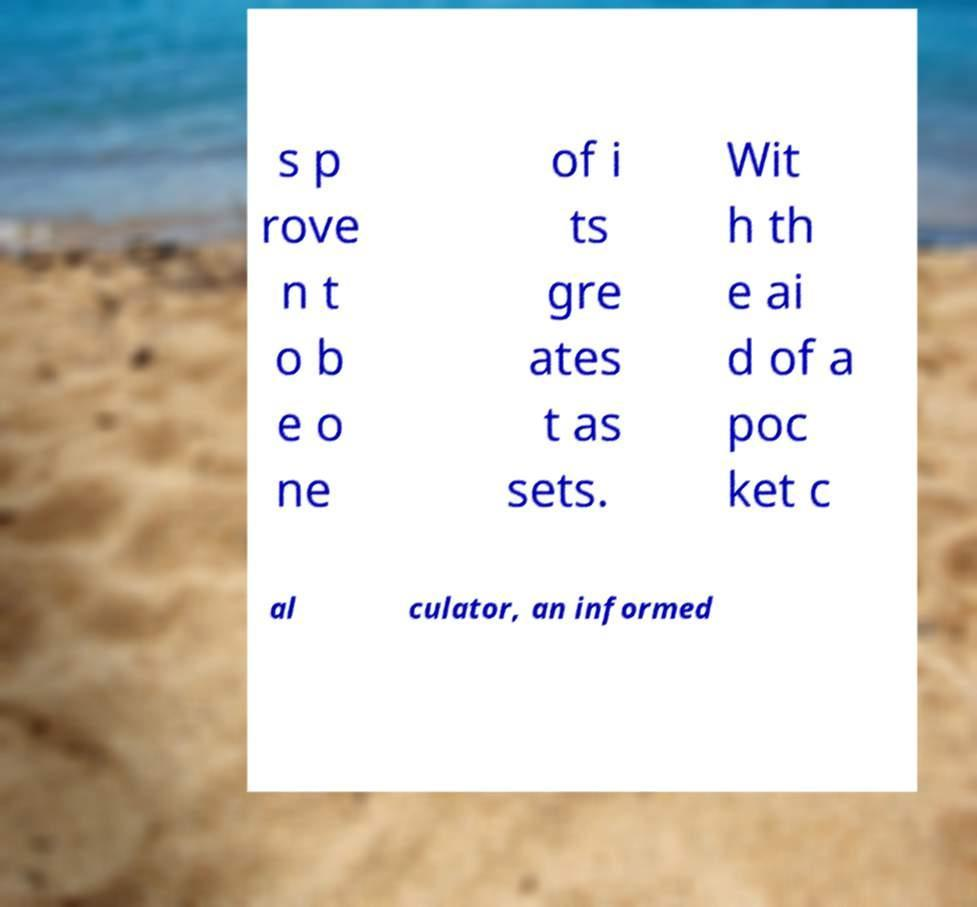What messages or text are displayed in this image? I need them in a readable, typed format. s p rove n t o b e o ne of i ts gre ates t as sets. Wit h th e ai d of a poc ket c al culator, an informed 